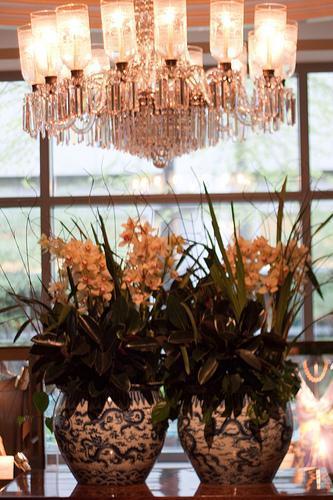How many pots are there?
Give a very brief answer. 2. 